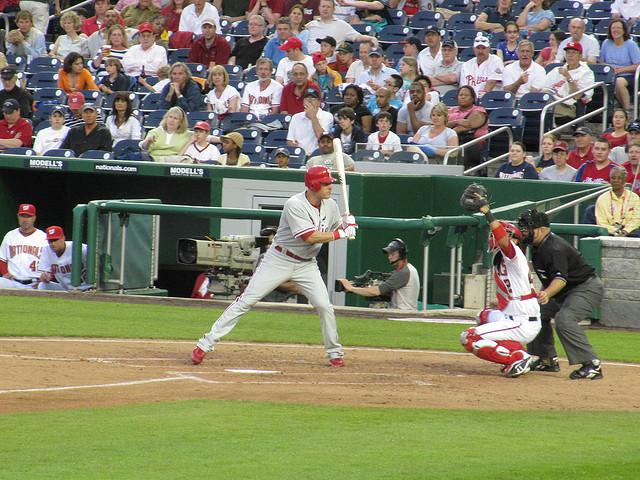Where is the ball? Please explain your reasoning. catcher's glove. Catcher has his hand up with the ball in his glove. 